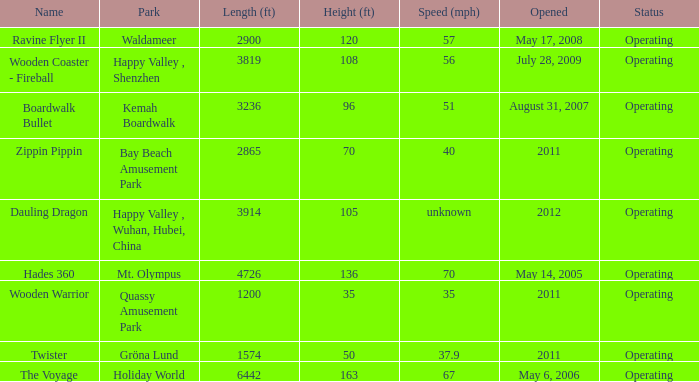What is the length of the coaster with the unknown speed 3914.0. 